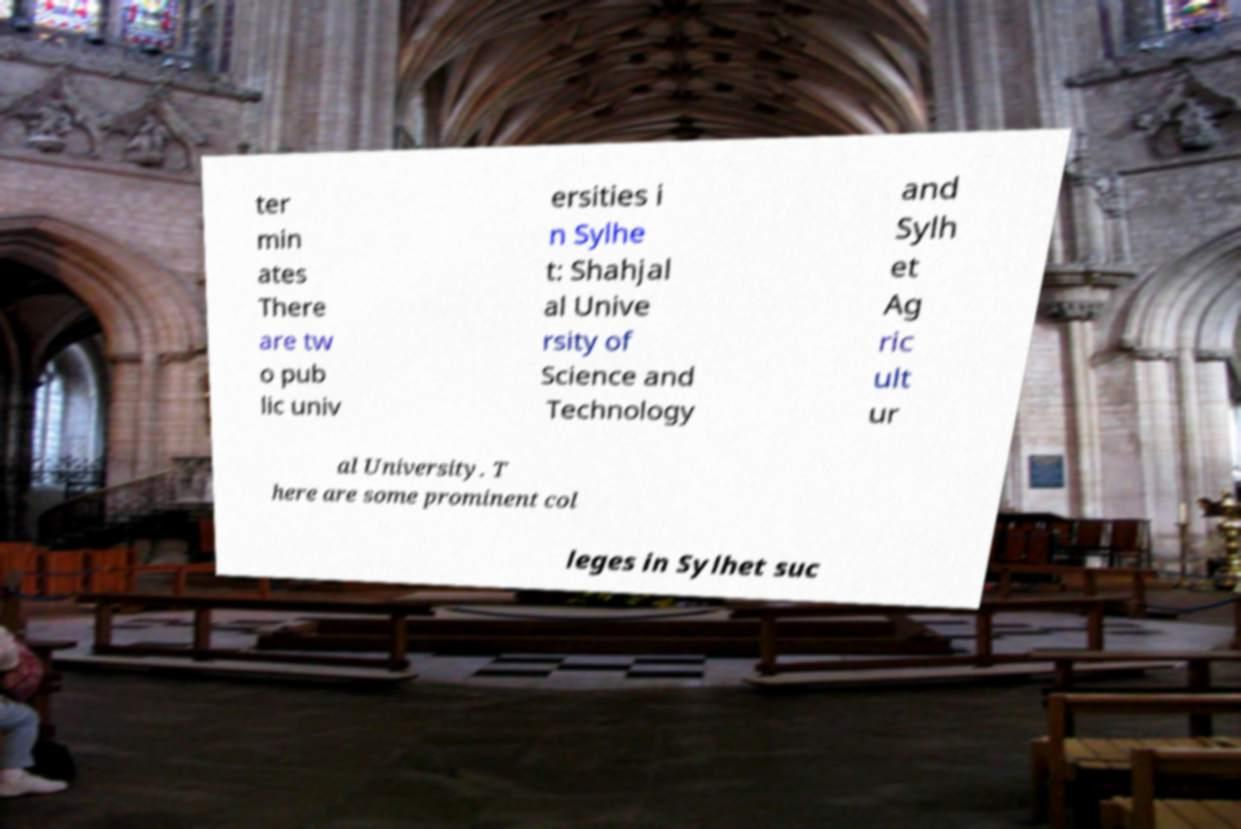Could you assist in decoding the text presented in this image and type it out clearly? ter min ates There are tw o pub lic univ ersities i n Sylhe t: Shahjal al Unive rsity of Science and Technology and Sylh et Ag ric ult ur al University. T here are some prominent col leges in Sylhet suc 